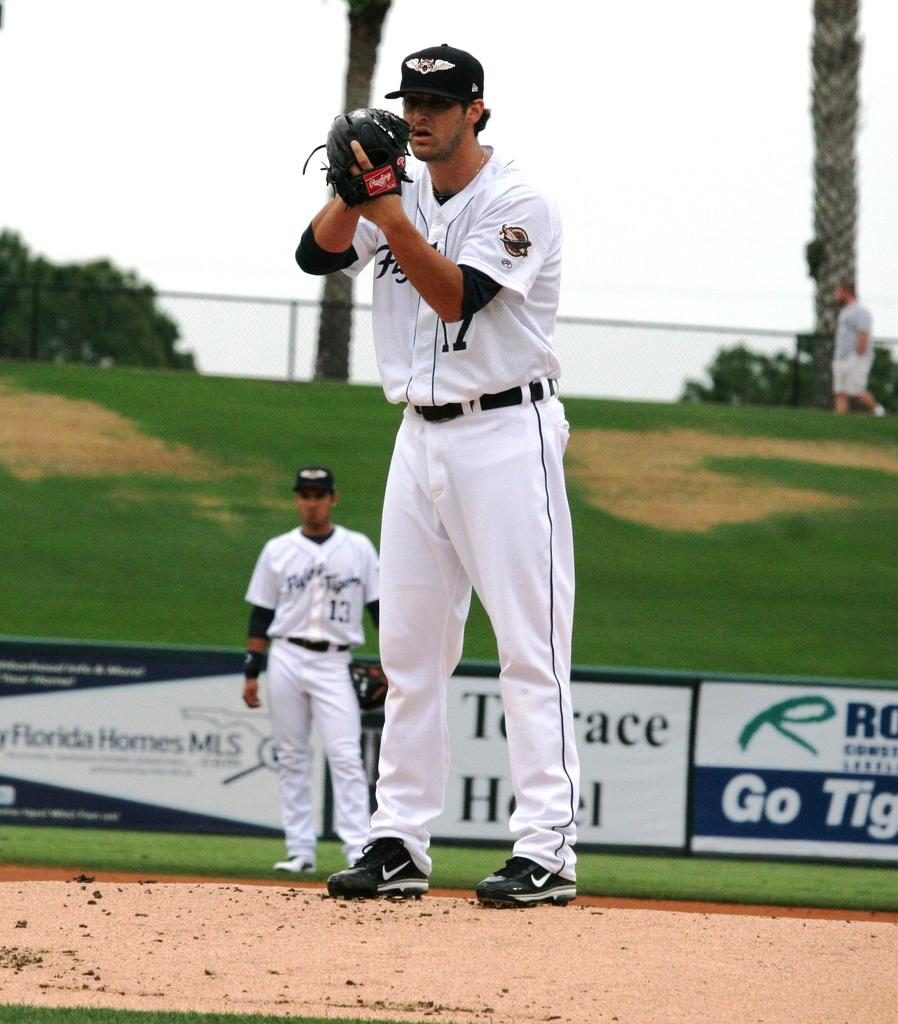<image>
Create a compact narrative representing the image presented. a pitcher on the mound on a baseball field with a sign for Florida Home MLS 